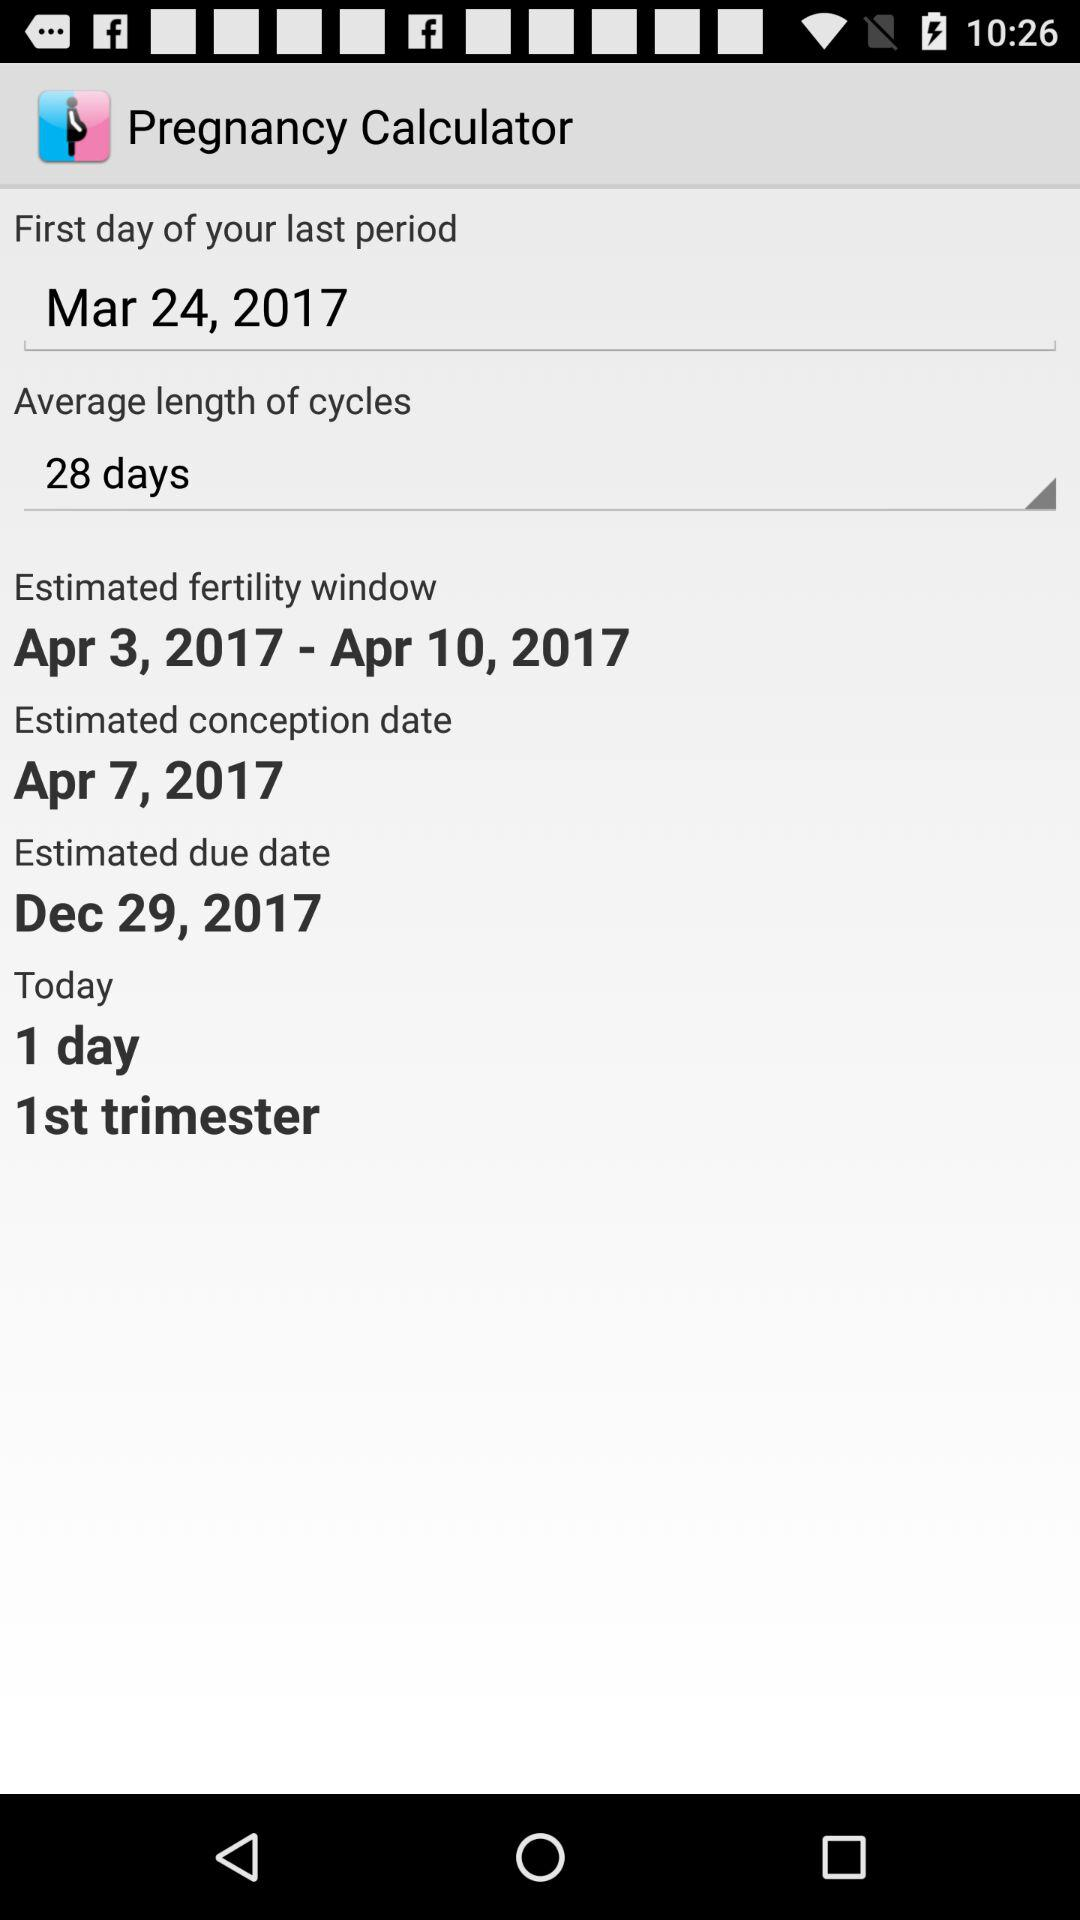What is the estimated conception date? The estimated conception date is April 7, 2017. 